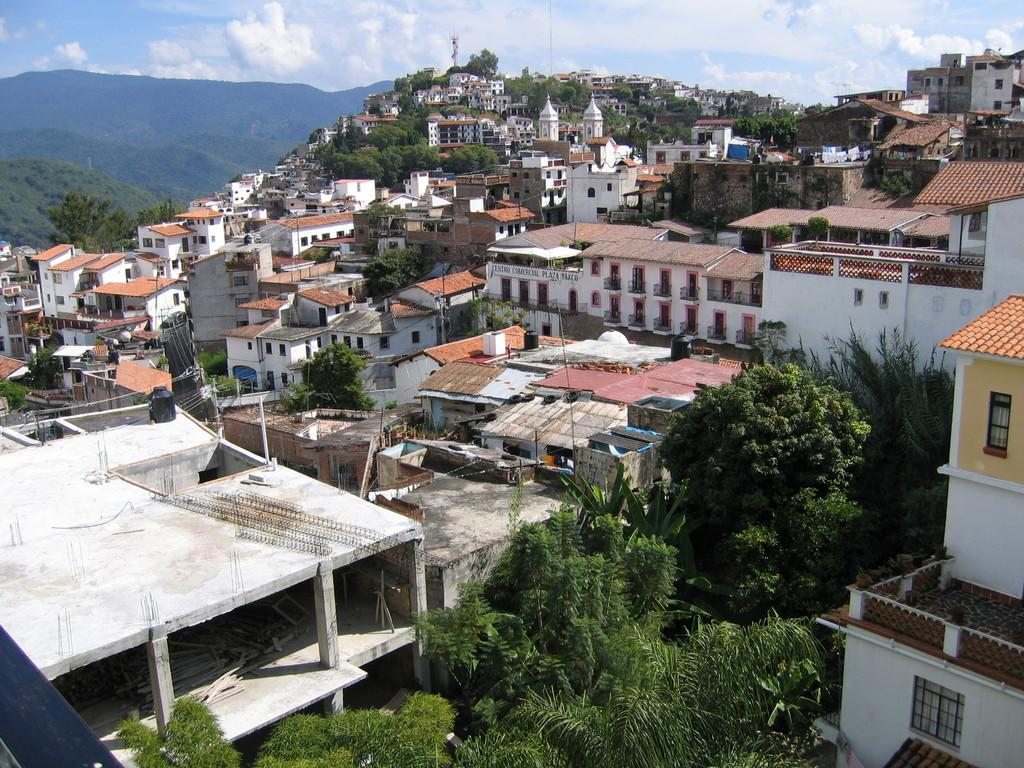What type of view is depicted in the image? The image is an aerial view. What natural elements can be seen in the image? There are trees in the image. What man-made structures are visible in the image? There are houses in the image. What geographical features are present in the image? There are hills in the image. What is the color of the sky in the image? The sky is blue in color. What atmospheric elements can be seen in the sky? Clouds are visible in the sky. What type of harmony can be heard in the image? There is no sound present in the image, so it is not possible to determine what type of harmony might be heard. 